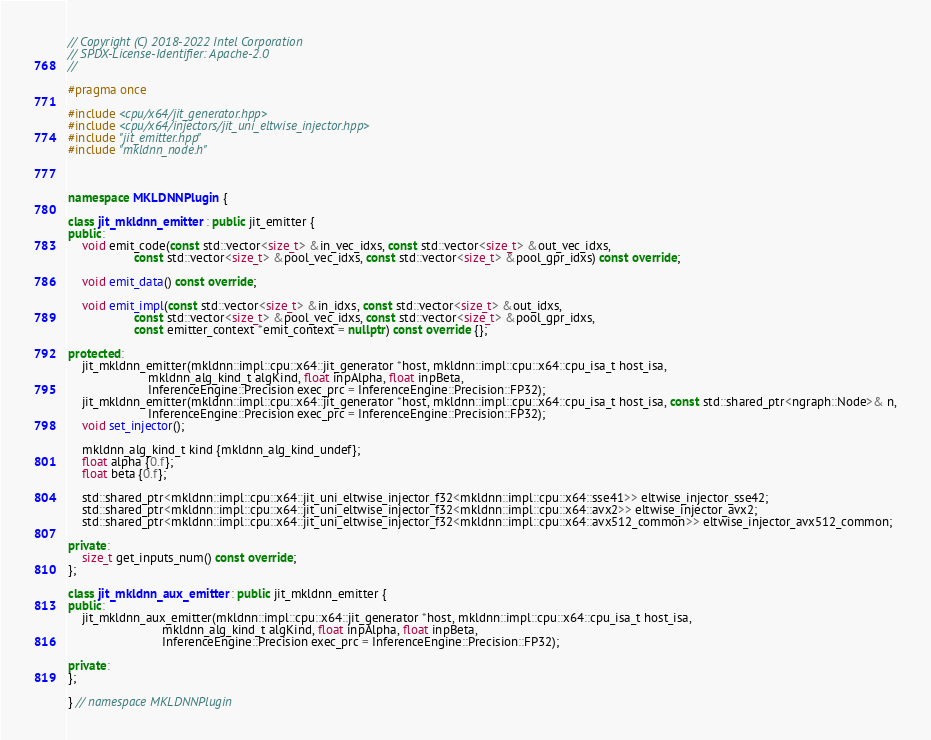<code> <loc_0><loc_0><loc_500><loc_500><_C++_>// Copyright (C) 2018-2022 Intel Corporation
// SPDX-License-Identifier: Apache-2.0
//

#pragma once

#include <cpu/x64/jit_generator.hpp>
#include <cpu/x64/injectors/jit_uni_eltwise_injector.hpp>
#include "jit_emitter.hpp"
#include "mkldnn_node.h"



namespace MKLDNNPlugin {

class jit_mkldnn_emitter : public jit_emitter {
public:
    void emit_code(const std::vector<size_t> &in_vec_idxs, const std::vector<size_t> &out_vec_idxs,
                   const std::vector<size_t> &pool_vec_idxs, const std::vector<size_t> &pool_gpr_idxs) const override;

    void emit_data() const override;

    void emit_impl(const std::vector<size_t> &in_idxs, const std::vector<size_t> &out_idxs,
                   const std::vector<size_t> &pool_vec_idxs, const std::vector<size_t> &pool_gpr_idxs,
                   const emitter_context *emit_context = nullptr) const override {};

protected:
    jit_mkldnn_emitter(mkldnn::impl::cpu::x64::jit_generator *host, mkldnn::impl::cpu::x64::cpu_isa_t host_isa,
                       mkldnn_alg_kind_t algKind, float inpAlpha, float inpBeta,
                       InferenceEngine::Precision exec_prc = InferenceEngine::Precision::FP32);
    jit_mkldnn_emitter(mkldnn::impl::cpu::x64::jit_generator *host, mkldnn::impl::cpu::x64::cpu_isa_t host_isa, const std::shared_ptr<ngraph::Node>& n,
                       InferenceEngine::Precision exec_prc = InferenceEngine::Precision::FP32);
    void set_injector();

    mkldnn_alg_kind_t kind {mkldnn_alg_kind_undef};
    float alpha {0.f};
    float beta {0.f};

    std::shared_ptr<mkldnn::impl::cpu::x64::jit_uni_eltwise_injector_f32<mkldnn::impl::cpu::x64::sse41>> eltwise_injector_sse42;
    std::shared_ptr<mkldnn::impl::cpu::x64::jit_uni_eltwise_injector_f32<mkldnn::impl::cpu::x64::avx2>> eltwise_injector_avx2;
    std::shared_ptr<mkldnn::impl::cpu::x64::jit_uni_eltwise_injector_f32<mkldnn::impl::cpu::x64::avx512_common>> eltwise_injector_avx512_common;

private:
    size_t get_inputs_num() const override;
};

class jit_mkldnn_aux_emitter : public jit_mkldnn_emitter {
public:
    jit_mkldnn_aux_emitter(mkldnn::impl::cpu::x64::jit_generator *host, mkldnn::impl::cpu::x64::cpu_isa_t host_isa,
                           mkldnn_alg_kind_t algKind, float inpAlpha, float inpBeta,
                           InferenceEngine::Precision exec_prc = InferenceEngine::Precision::FP32);

private:
};

} // namespace MKLDNNPlugin</code> 